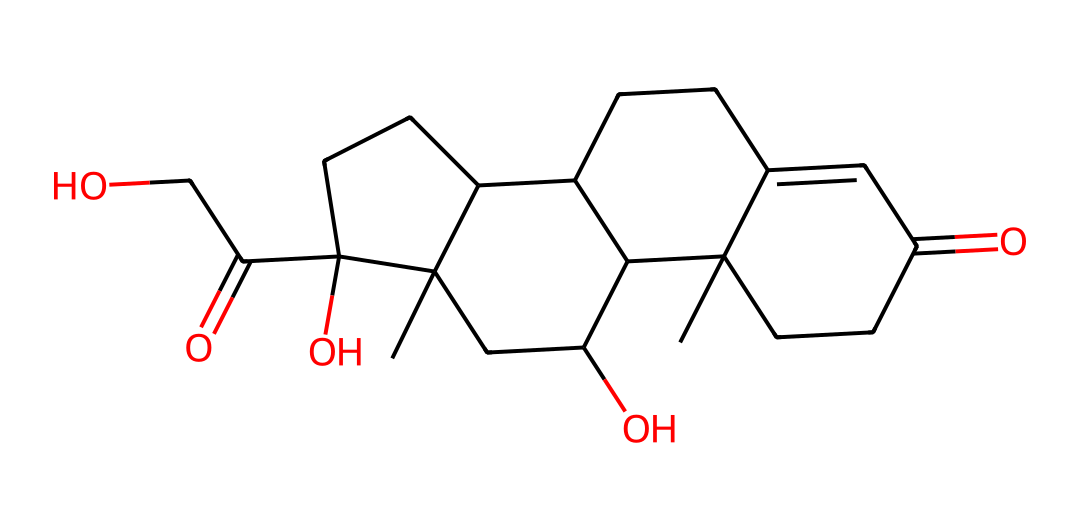What is the molecular formula of cortisol? By analyzing the structure provided by the SMILES representation, we can determine the number of each type of atom present. The breakdown shows there are 21 carbons (C), 30 hydrogens (H), and 5 oxygens (O), leading to the molecular formula C21H30O5.
Answer: C21H30O5 How many chiral centers are present in cortisol? A chiral center is identified by a carbon atom connected to four different substituents. By examining the structure, there are four such carbon atoms, indicating that cortisol has four chiral centers.
Answer: 4 What type of chemical compound is cortisol classified as? Cortisol falls under the category of steroids, which are characterized by a specific arrangement of carbon atoms forming a core steroid structure. Given its structure with multiple fused rings, it fits this classification.
Answer: steroid What role does the hydroxyl group play in cortisol's functionality? The presence of hydroxyl (–OH) groups in cortisol contributes to its hydrophilicity, allowing it to interact with biological receptors. This property impacts its function as a hormone by facilitating binding to specific receptors in target cells.
Answer: hydrophilicity How many rings are present in the structure of cortisol? By observing the fused rings that define its steroid structure within the SMILES representation, there are four rings present: three six-membered rings and one five-membered ring.
Answer: 4 Which functional group is primarily responsible for cortisol's classification as a hormone? The ketone functional group (C=O) plays a crucial role in hormone activity by enabling interactions with biological targets, and it is prominently featured in the structure. This interaction is vital for its function as a stress hormone.
Answer: ketone 